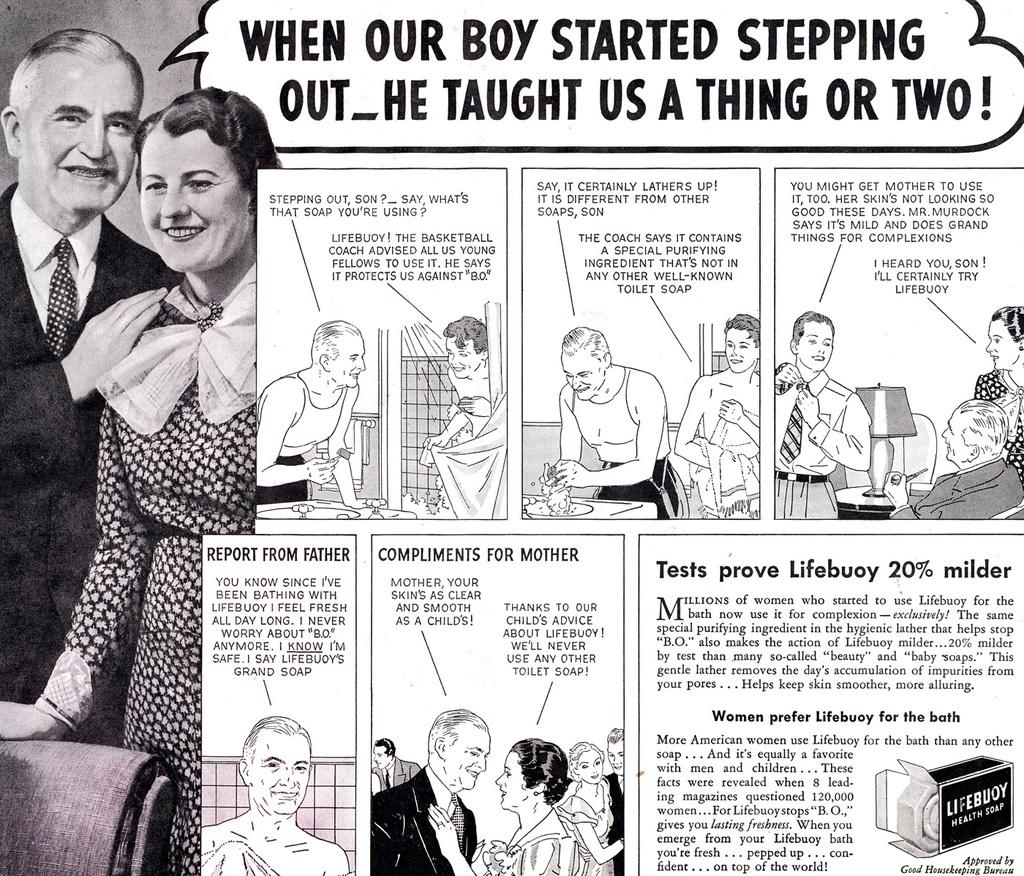What is the main subject of the newspaper clipping in the image? The newspaper clipping contains a picture of a couple. What else can be found on the newspaper clipping besides the picture? There is text and cartoon images on the newspaper clipping. What type of thrill ride is depicted in the newspaper clipping? There is no thrill ride depicted in the newspaper clipping; it features a picture of a couple and other elements. 